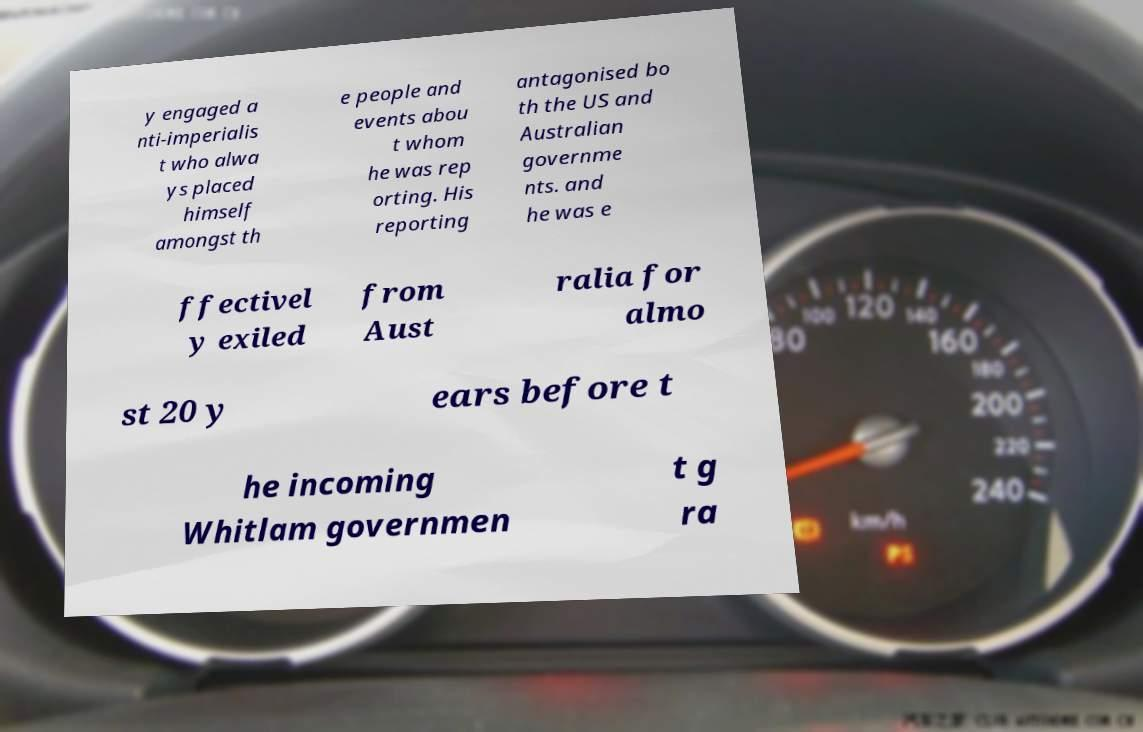Can you accurately transcribe the text from the provided image for me? y engaged a nti-imperialis t who alwa ys placed himself amongst th e people and events abou t whom he was rep orting. His reporting antagonised bo th the US and Australian governme nts. and he was e ffectivel y exiled from Aust ralia for almo st 20 y ears before t he incoming Whitlam governmen t g ra 